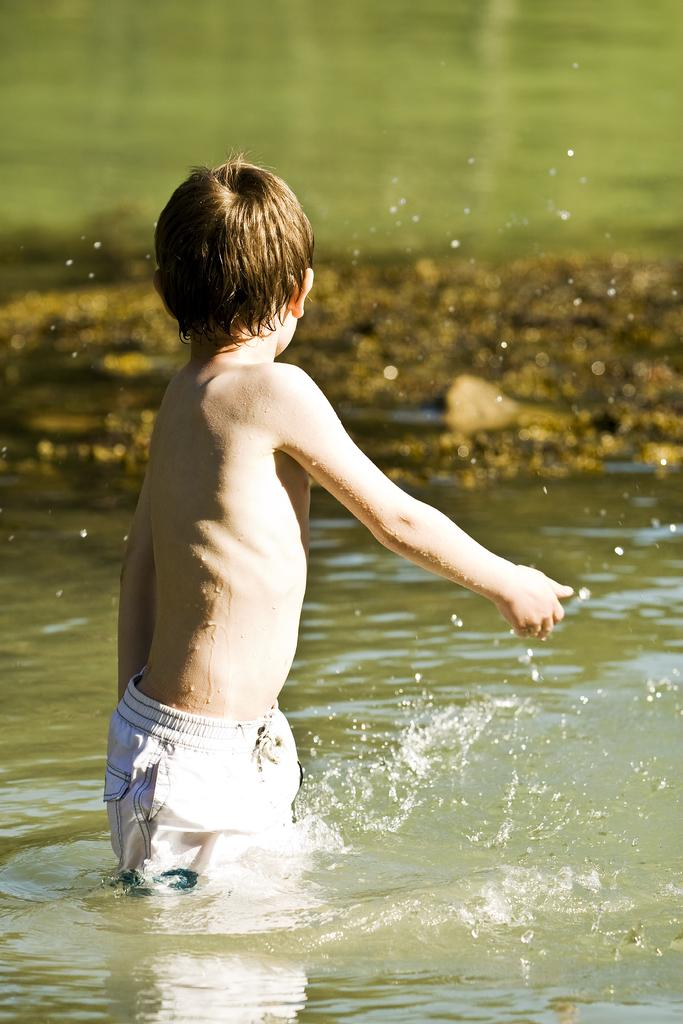What is the person in the image doing? The person is in the water. What type of terrain can be seen in the image? There is sand visible in the image. What color is the background of the image? The background of the image has a green color. What type of hat is the frog wearing in the image? There is no frog or hat present in the image. What invention is being demonstrated in the image? There is no invention being demonstrated in the image; it simply shows a person in the water with sand and a green background. 